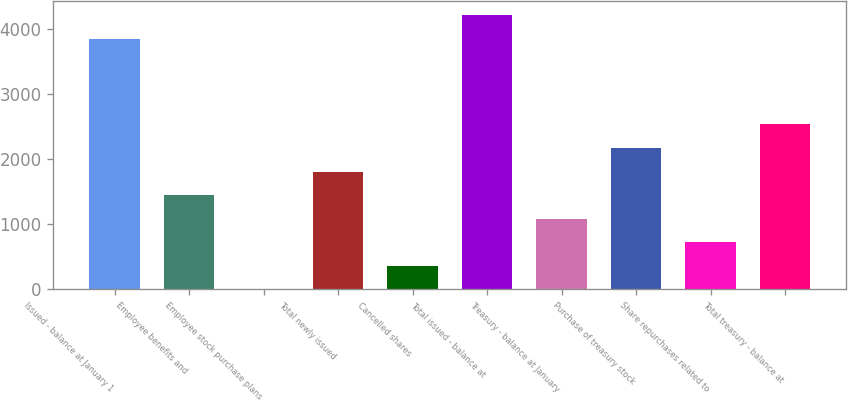<chart> <loc_0><loc_0><loc_500><loc_500><bar_chart><fcel>Issued - balance at January 1<fcel>Employee benefits and<fcel>Employee stock purchase plans<fcel>Total newly issued<fcel>Cancelled shares<fcel>Total issued - balance at<fcel>Treasury - balance at January<fcel>Purchase of treasury stock<fcel>Share repurchases related to<fcel>Total treasury - balance at<nl><fcel>3848.38<fcel>1448.12<fcel>1.4<fcel>1809.8<fcel>363.08<fcel>4210.06<fcel>1086.44<fcel>2171.48<fcel>724.76<fcel>2533.16<nl></chart> 